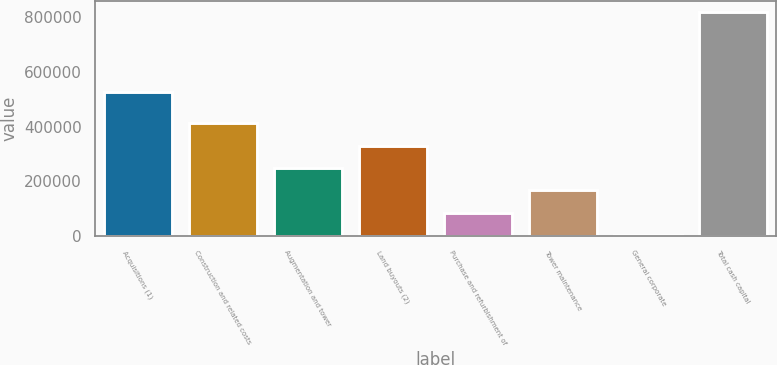<chart> <loc_0><loc_0><loc_500><loc_500><bar_chart><fcel>Acquisitions (1)<fcel>Construction and related costs<fcel>Augmentation and tower<fcel>Land buyouts (2)<fcel>Purchase and refurbishment of<fcel>Tower maintenance<fcel>General corporate<fcel>Total cash capital<nl><fcel>525802<fcel>411606<fcel>248953<fcel>330279<fcel>86300.3<fcel>167627<fcel>4974<fcel>818237<nl></chart> 